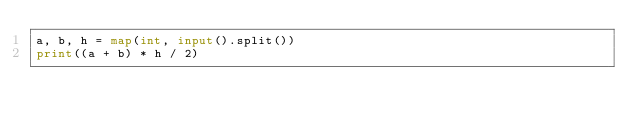Convert code to text. <code><loc_0><loc_0><loc_500><loc_500><_Python_>a, b, h = map(int, input().split())
print((a + b) * h / 2)</code> 